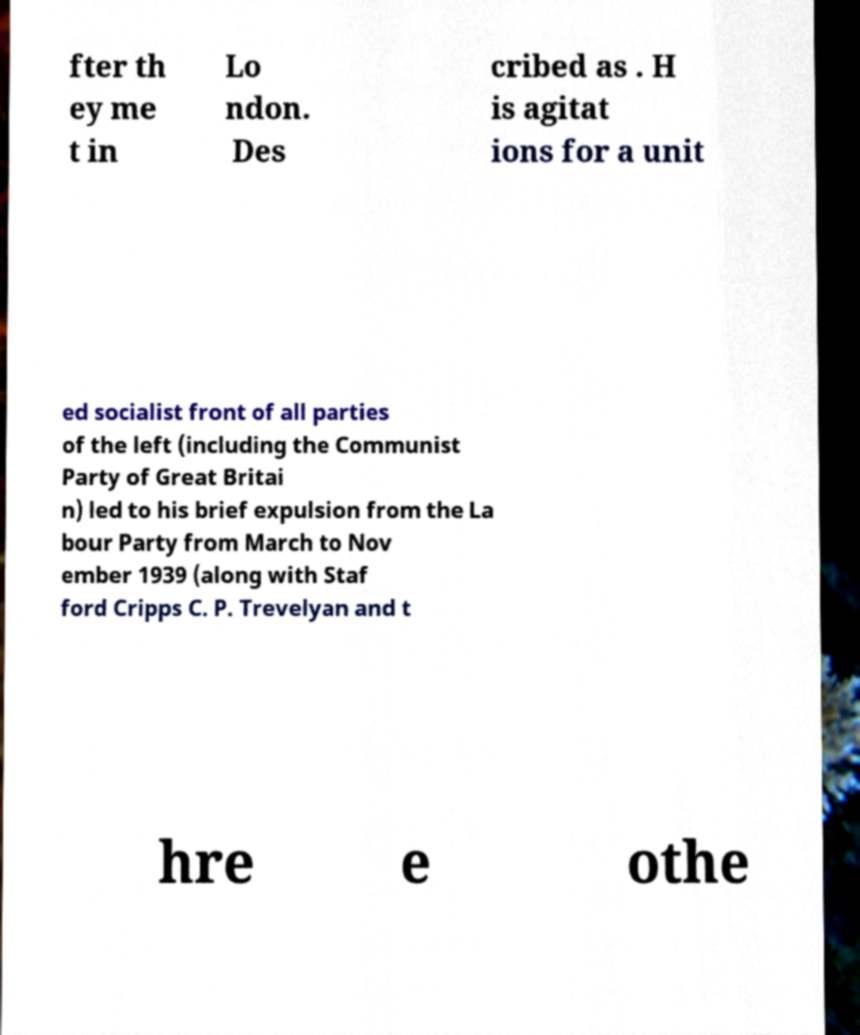Please read and relay the text visible in this image. What does it say? fter th ey me t in Lo ndon. Des cribed as . H is agitat ions for a unit ed socialist front of all parties of the left (including the Communist Party of Great Britai n) led to his brief expulsion from the La bour Party from March to Nov ember 1939 (along with Staf ford Cripps C. P. Trevelyan and t hre e othe 